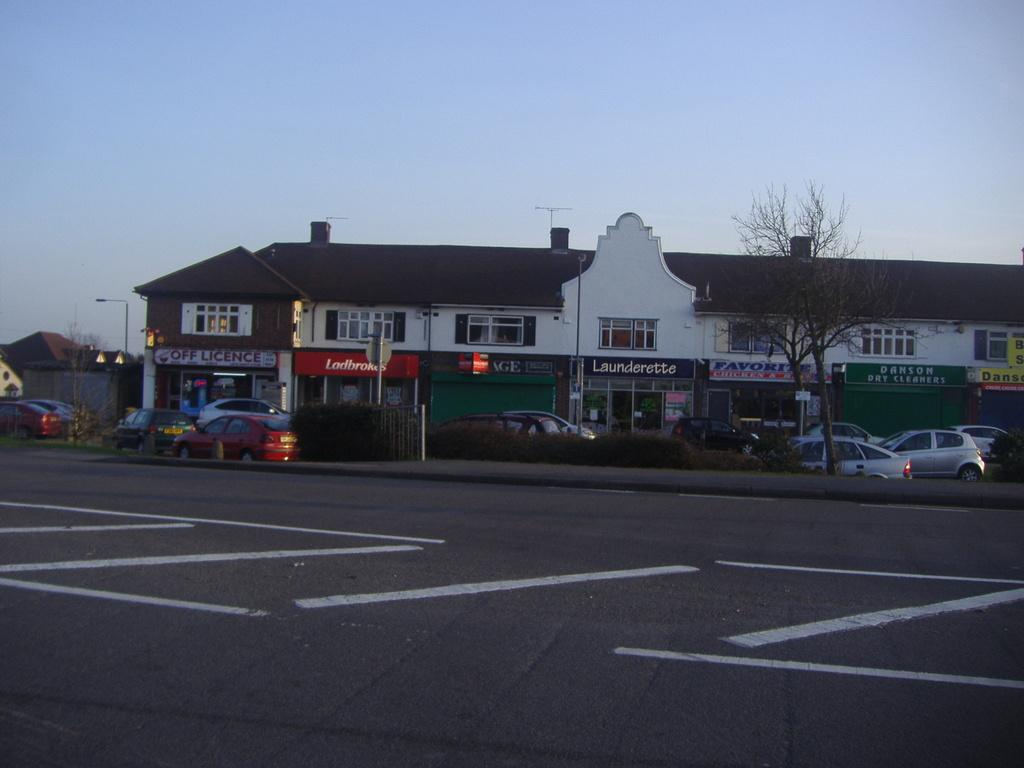What type of structure is present in the image? There is a building in the image. What can be seen beside the road in the image? There are cars beside the road in the image. What type of vegetation is on the right side of the image? There is a tree on the right side of the image. What is visible in the background of the image? The sky is visible in the background of the image. Can you see any feathers floating in the air in the image? There are no feathers visible in the image. Is there any eggnog being served in the image? There is no eggnog present in the image. 